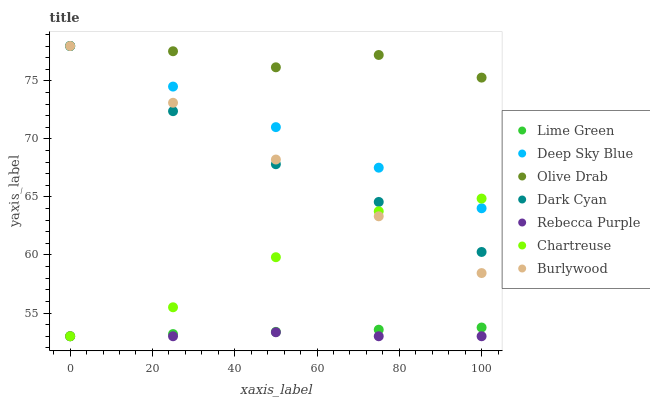Does Rebecca Purple have the minimum area under the curve?
Answer yes or no. Yes. Does Olive Drab have the maximum area under the curve?
Answer yes or no. Yes. Does Chartreuse have the minimum area under the curve?
Answer yes or no. No. Does Chartreuse have the maximum area under the curve?
Answer yes or no. No. Is Deep Sky Blue the smoothest?
Answer yes or no. Yes. Is Olive Drab the roughest?
Answer yes or no. Yes. Is Chartreuse the smoothest?
Answer yes or no. No. Is Chartreuse the roughest?
Answer yes or no. No. Does Chartreuse have the lowest value?
Answer yes or no. Yes. Does Deep Sky Blue have the lowest value?
Answer yes or no. No. Does Olive Drab have the highest value?
Answer yes or no. Yes. Does Chartreuse have the highest value?
Answer yes or no. No. Is Rebecca Purple less than Burlywood?
Answer yes or no. Yes. Is Dark Cyan greater than Lime Green?
Answer yes or no. Yes. Does Burlywood intersect Deep Sky Blue?
Answer yes or no. Yes. Is Burlywood less than Deep Sky Blue?
Answer yes or no. No. Is Burlywood greater than Deep Sky Blue?
Answer yes or no. No. Does Rebecca Purple intersect Burlywood?
Answer yes or no. No. 